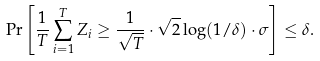Convert formula to latex. <formula><loc_0><loc_0><loc_500><loc_500>\Pr \left [ \frac { 1 } { T } \sum ^ { T } _ { i = 1 } Z _ { i } \geq \frac { 1 } { \sqrt { T } } \cdot \sqrt { 2 } \log ( 1 / \delta ) \cdot \sigma \right ] \leq \delta .</formula> 